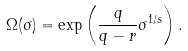<formula> <loc_0><loc_0><loc_500><loc_500>\Omega ( \sigma ) = \exp \left ( \frac { q } { q - r } \sigma ^ { 1 / s } \right ) .</formula> 